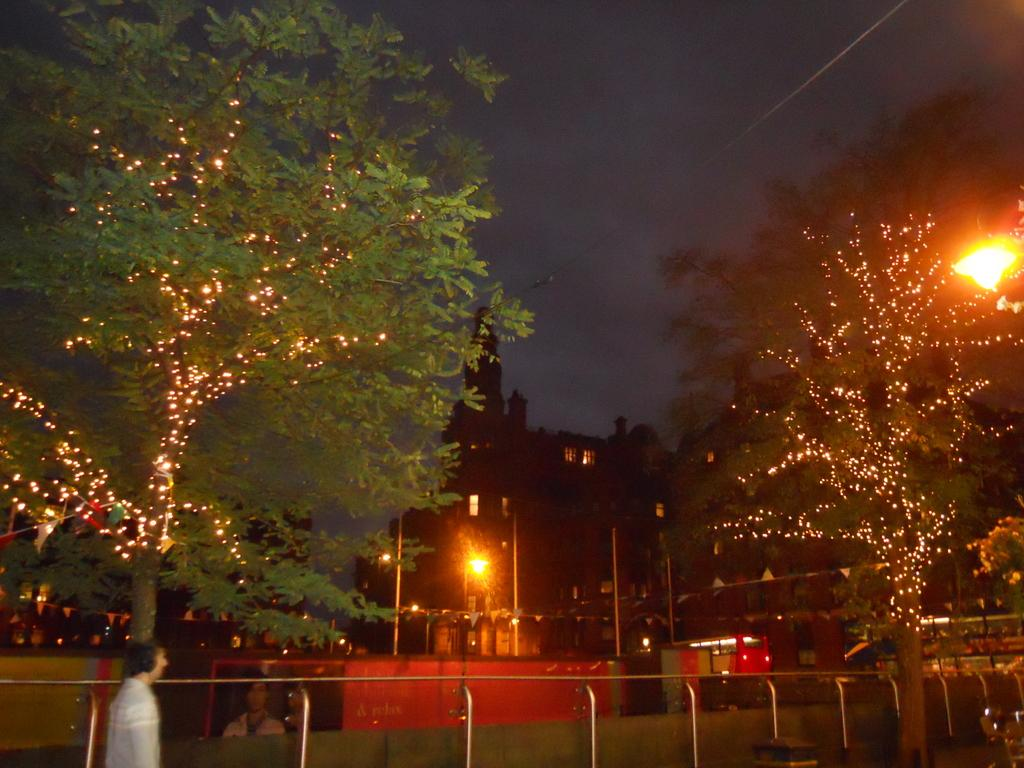What is the person in the image doing? The person in the image is walking on the road. What can be seen alongside the road in the image? There is a fence in the image. What other structures are present in the image? There is a wall, trees with lights, light poles, and buildings in the image. What is the condition of the sky in the background of the image? The sky in the background of the image is dark. Where can the person be seen raking leaves in the image? There is no rake or leaves being raked in the image. What type of pies are being sold at the river in the image? There is no river or pies being sold in the image. 